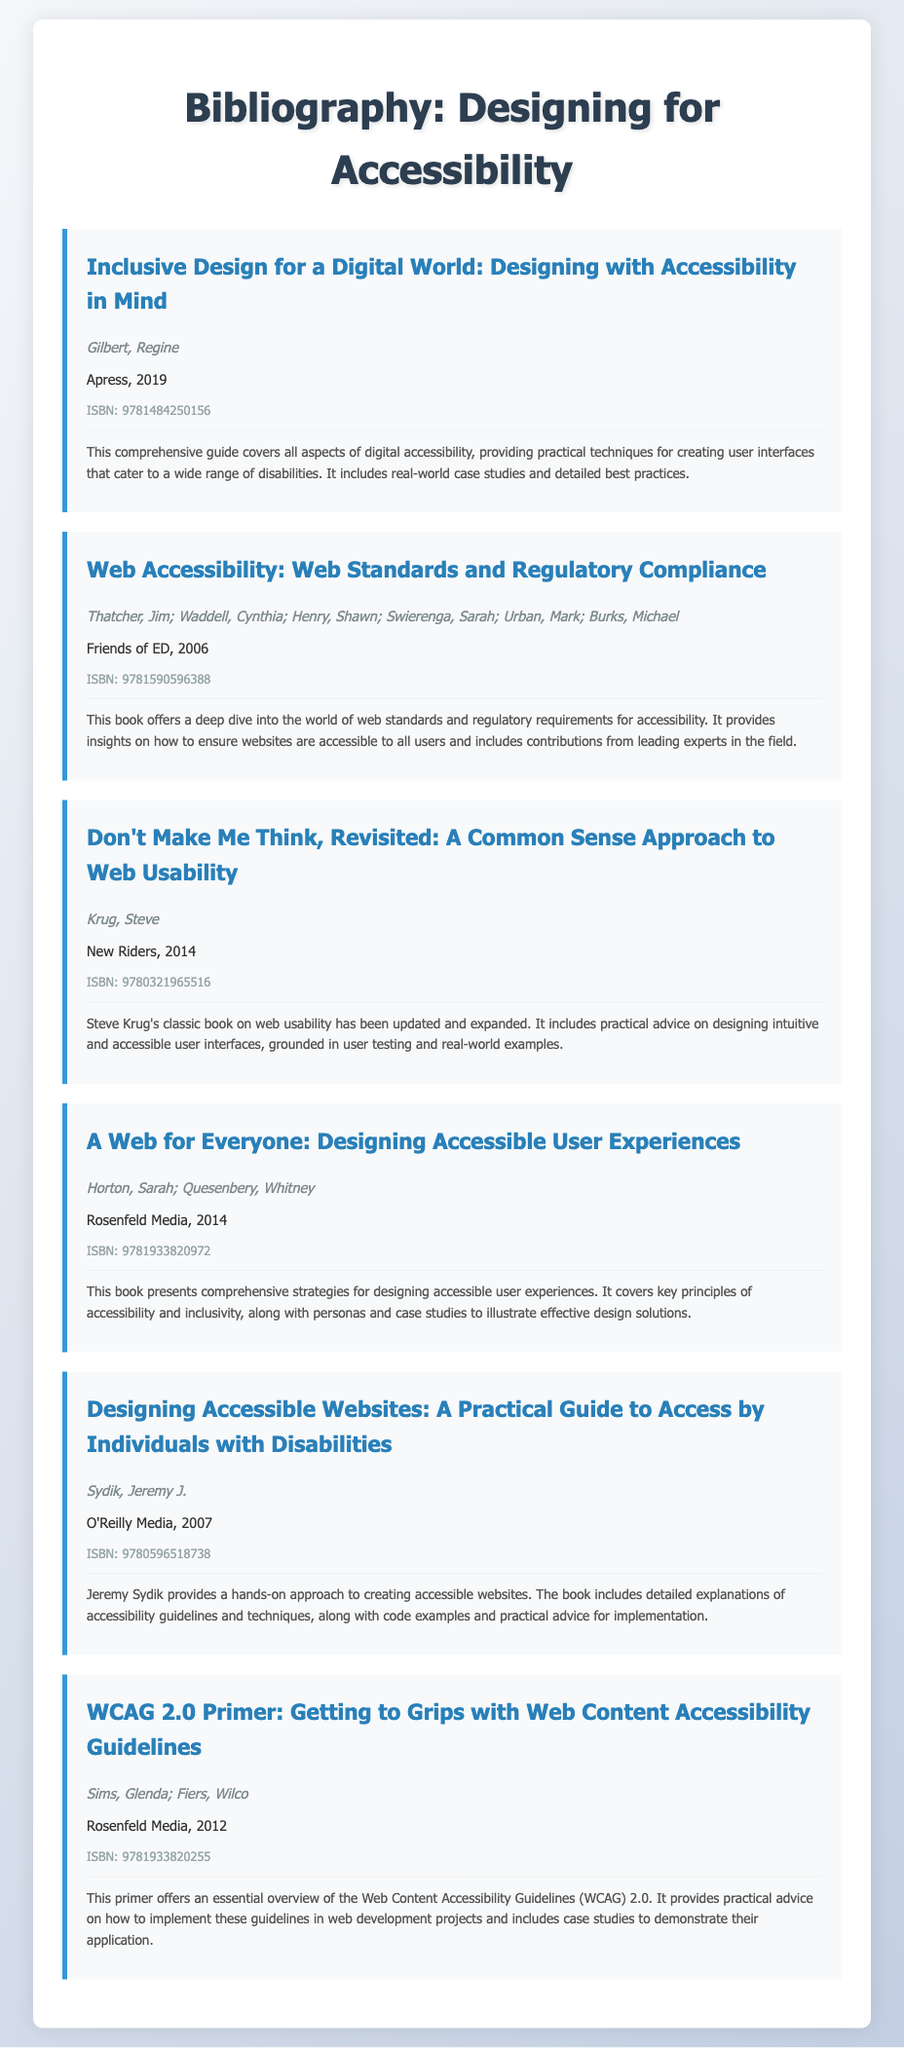What is the title of the first book? The title of the first book is found in the first entry of the bibliography.
Answer: Inclusive Design for a Digital World: Designing with Accessibility in Mind Who is the author of "Don't Make Me Think, Revisited"? The author's name can be found in the entry for that specific book.
Answer: Steve Krug In what year was "A Web for Everyone" published? The publication year is included in the details of that specific book entry.
Answer: 2014 How many authors contributed to "Web Accessibility"? The number of authors is indicated in the authors' section of that book entry.
Answer: Six What is the ISBN of "WCAG 2.0 Primer"? The ISBN is provided in the respective book's ISBN section.
Answer: 9781933820255 Which publishing company released "Designing Accessible Websites"? The publishing company is stated in the details section of that entry.
Answer: O'Reilly Media What is the primary focus of "Inclusive Design for a Digital World"? This can be inferred from the summary of the book, describing its main content.
Answer: Digital accessibility Which book includes case studies as part of its content? The summaries provide insights into the content style of each book.
Answer: Inclusive Design for a Digital World: Designing with Accessibility in Mind What is the subtitle of the book by Horton and Quesenbery? The subtitle can be found in the title section of their book entry.
Answer: Designing Accessible User Experiences 